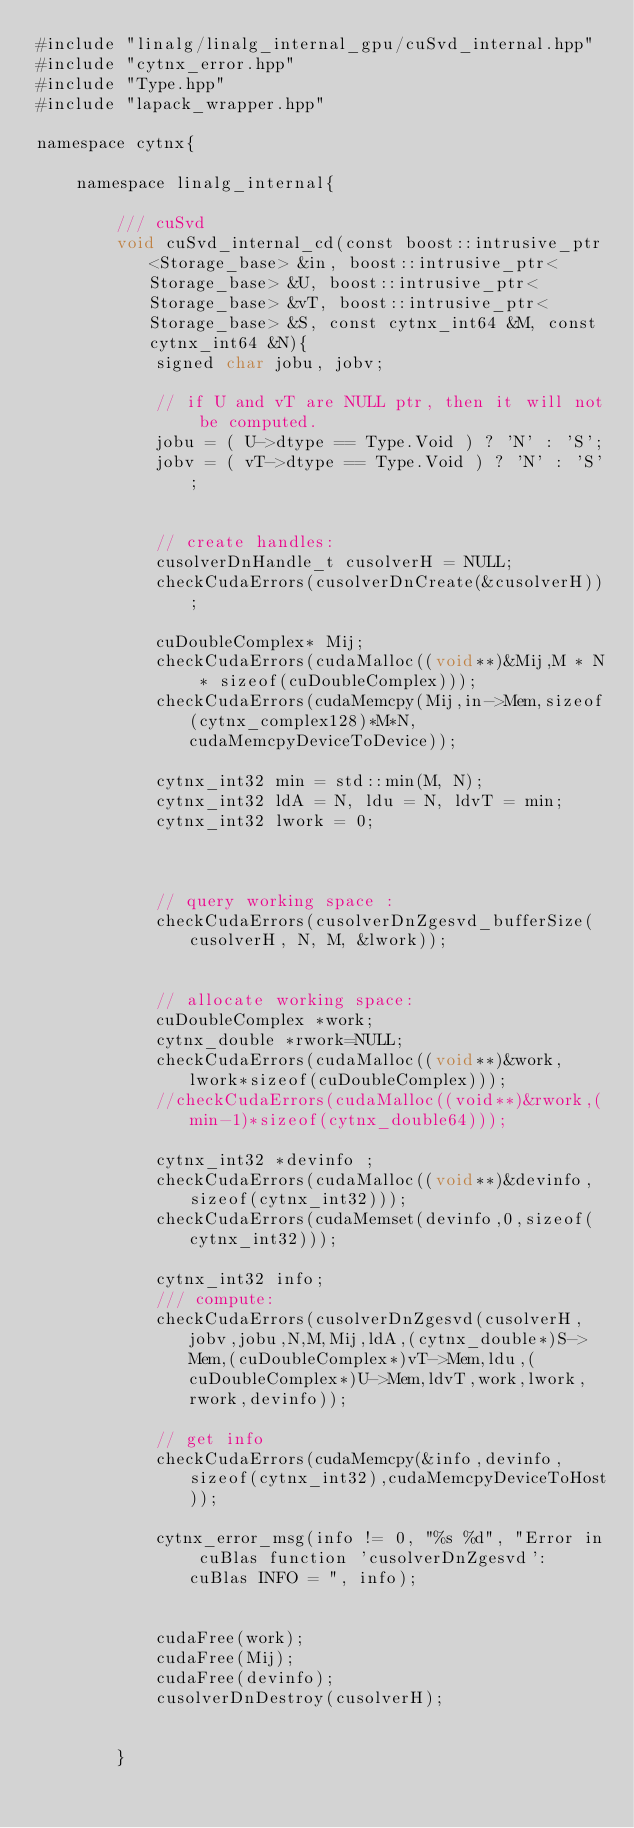<code> <loc_0><loc_0><loc_500><loc_500><_Cuda_>#include "linalg/linalg_internal_gpu/cuSvd_internal.hpp"
#include "cytnx_error.hpp"
#include "Type.hpp"
#include "lapack_wrapper.hpp"

namespace cytnx{

    namespace linalg_internal{

        /// cuSvd
        void cuSvd_internal_cd(const boost::intrusive_ptr<Storage_base> &in, boost::intrusive_ptr<Storage_base> &U, boost::intrusive_ptr<Storage_base> &vT, boost::intrusive_ptr<Storage_base> &S, const cytnx_int64 &M, const cytnx_int64 &N){
            signed char jobu, jobv;

            // if U and vT are NULL ptr, then it will not be computed. 
            jobu = ( U->dtype == Type.Void ) ? 'N' : 'S';
            jobv = ( vT->dtype == Type.Void ) ? 'N' : 'S';


            // create handles:
            cusolverDnHandle_t cusolverH = NULL;
            checkCudaErrors(cusolverDnCreate(&cusolverH));

            cuDoubleComplex* Mij;
            checkCudaErrors(cudaMalloc((void**)&Mij,M * N * sizeof(cuDoubleComplex)));
            checkCudaErrors(cudaMemcpy(Mij,in->Mem,sizeof(cytnx_complex128)*M*N,cudaMemcpyDeviceToDevice));

            cytnx_int32 min = std::min(M, N);
            cytnx_int32 ldA = N, ldu = N, ldvT = min;
            cytnx_int32 lwork = 0;



            // query working space :
            checkCudaErrors(cusolverDnZgesvd_bufferSize(cusolverH, N, M, &lwork));


            // allocate working space:
            cuDoubleComplex *work;
            cytnx_double *rwork=NULL;
            checkCudaErrors(cudaMalloc((void**)&work,lwork*sizeof(cuDoubleComplex)));
            //checkCudaErrors(cudaMalloc((void**)&rwork,(min-1)*sizeof(cytnx_double64)));    

            cytnx_int32 *devinfo ;
            checkCudaErrors(cudaMalloc((void**)&devinfo,sizeof(cytnx_int32)));
            checkCudaErrors(cudaMemset(devinfo,0,sizeof(cytnx_int32)));

            cytnx_int32 info;
            /// compute:
            checkCudaErrors(cusolverDnZgesvd(cusolverH,jobv,jobu,N,M,Mij,ldA,(cytnx_double*)S->Mem,(cuDoubleComplex*)vT->Mem,ldu,(cuDoubleComplex*)U->Mem,ldvT,work,lwork,rwork,devinfo));

            // get info
            checkCudaErrors(cudaMemcpy(&info,devinfo,sizeof(cytnx_int32),cudaMemcpyDeviceToHost));

            cytnx_error_msg(info != 0, "%s %d", "Error in cuBlas function 'cusolverDnZgesvd': cuBlas INFO = ", info);


            cudaFree(work);
            cudaFree(Mij);
            cudaFree(devinfo);
            cusolverDnDestroy(cusolverH);


        }</code> 